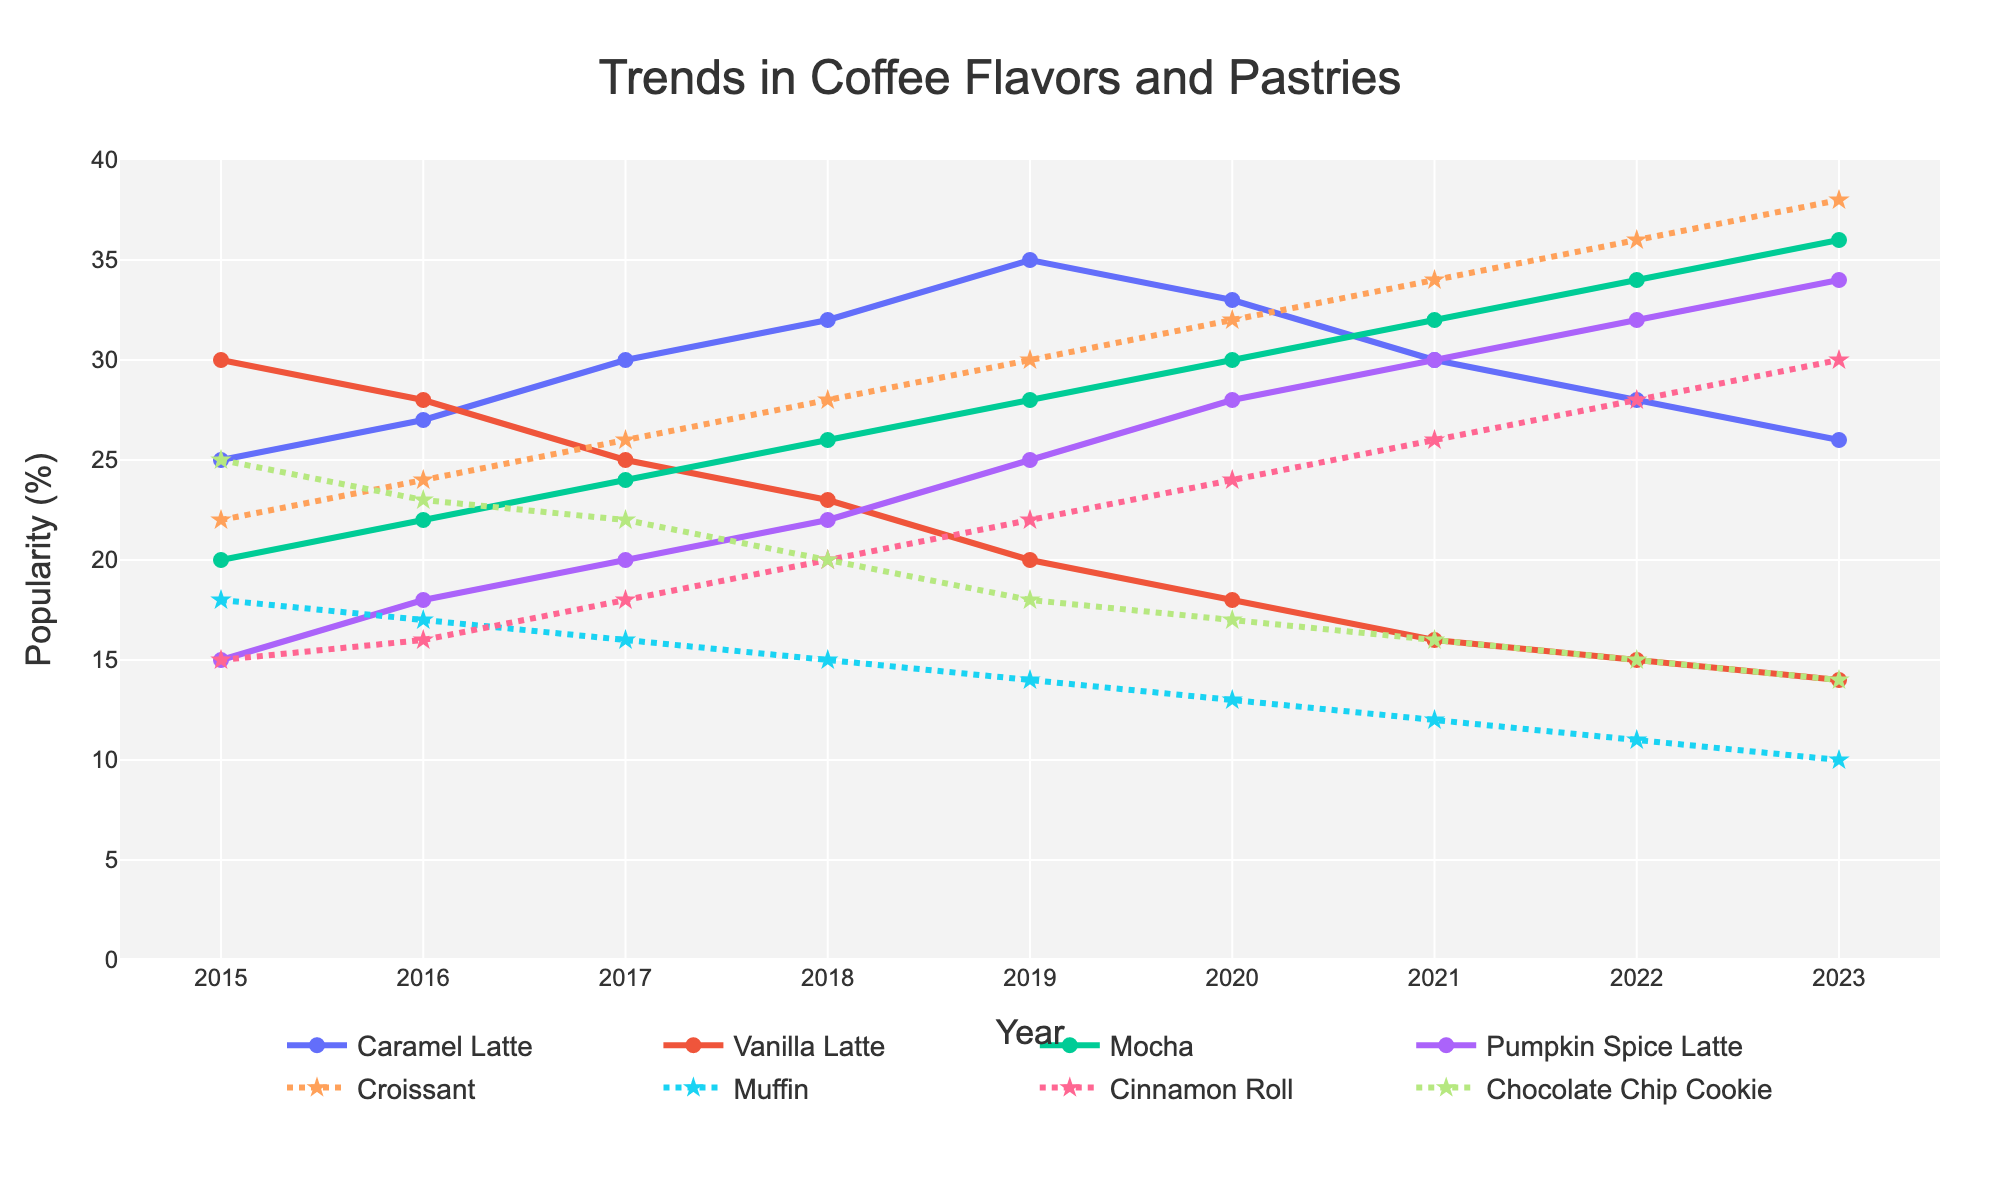Which coffee flavor saw the highest popularity in 2023? In 2023, the Mocha flavor had the highest popularity with a score of 36.
Answer: Mocha Between 2016 and 2019, which flavor of latte decreased the most in popularity? Starting in 2016, Vanilla Latte had a score of 28. By 2019, it was down to 20, making a total decrease of 8 points. The other flavors did not decrease as much.
Answer: Vanilla Latte Which year saw the biggest increase in Pumpkin Spice Latte's popularity compared to the previous year? From 2019 to 2020, the popularity of Pumpkin Spice Latte increased from 25 to 28, a difference of 3 points.
Answer: 2020 In what year did Muffins and Chocolate Chip Cookies have the same popularity percentage? In 2015, both Muffins and Chocolate Chip Cookies had a popularity of 25%.
Answer: 2015 By how much did the popularity of Cinnamon Rolls increase from 2015 to 2023? The popularity of Cinnamon Rolls in 2015 was 15%, and by 2023 it was 30%. The increase is 30 - 15 = 15%.
Answer: 15% Which pastry became the most popular over the entire timeframe and in what year did it achieve this? The Croissant became the most popular over time, reaching its peak of 38% in 2023.
Answer: Croissant, 2023 Comparing all coffee flavors in 2021, how much more popular was Mocha than Vanilla Latte? In 2021, Mocha had a popularity of 32% and Vanilla Latte had 16%, so Mocha was 16 points more popular.
Answer: 16% Which coffee flavor's popularity was highest in 2015, and how does it change by 2023? In 2015, Vanilla Latte was the most popular at 30%. By 2023, it decreased to 14%, a drop of 16 points.
Answer: Vanilla Latte, decreased by 16% What was the average popularity of Muffins from 2015 to 2023? The values for Muffins from 2015 to 2023 are [18, 17, 16, 15, 14, 13, 12, 11, 10]. The sum of these values is 126. The average is 126/9 = 14.
Answer: 14% 